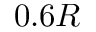<formula> <loc_0><loc_0><loc_500><loc_500>0 . 6 R</formula> 